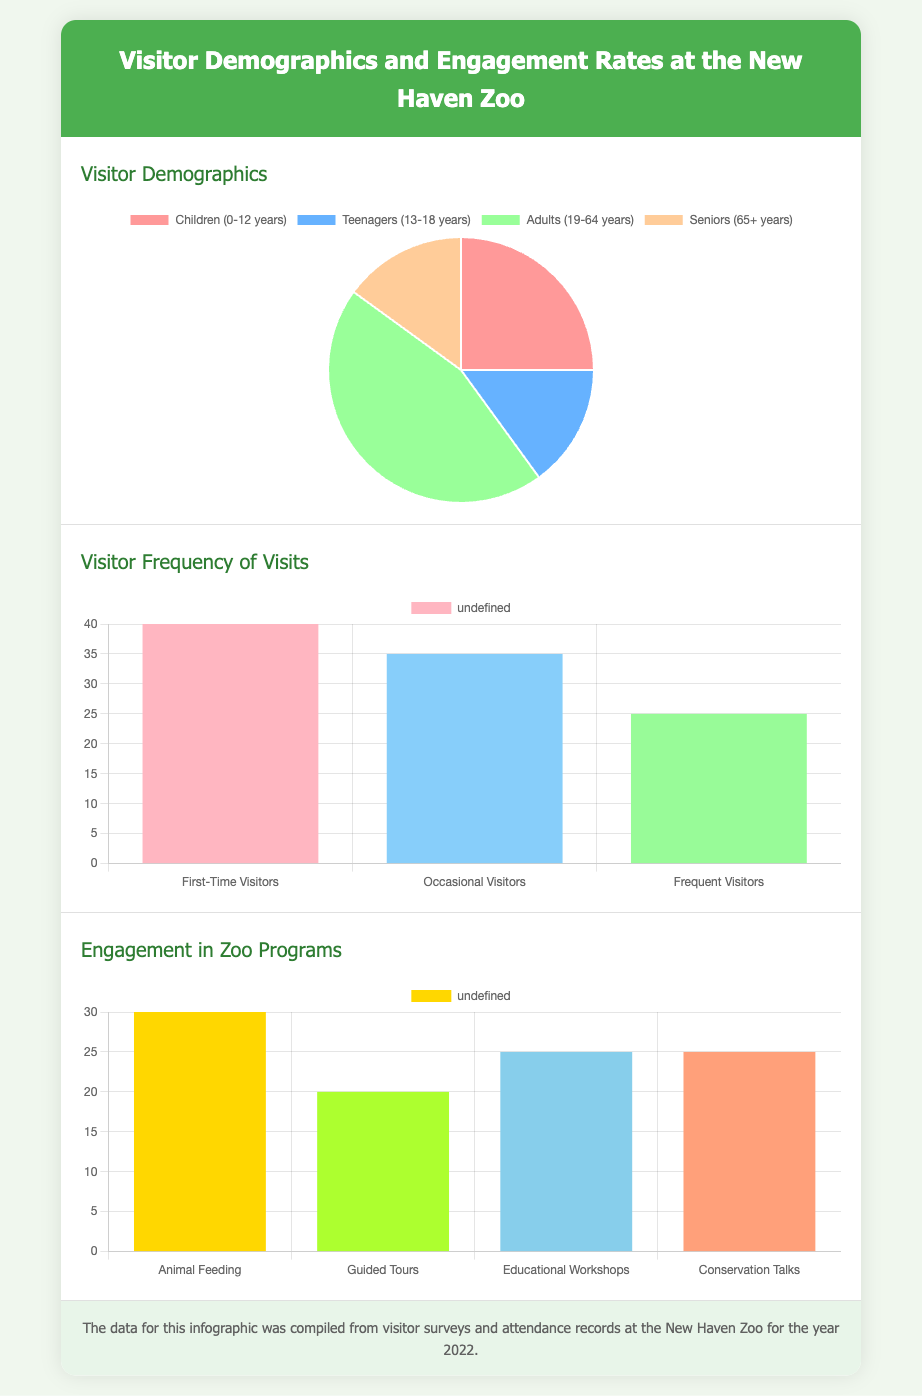What percentage of visitors are adults aged 19-64 years? The demographics chart shows that adults aged 19-64 years represent 45% of the visitors.
Answer: 45% What is the number of first-time visitors? The frequency chart indicates that there are 40 first-time visitors.
Answer: 40 Which engagement program has the highest participation rate? The engagement chart shows that Animal Feeding has the highest participation rate at 30.
Answer: Animal Feeding What is the total percentage of visitors who are seniors (65+ years)? According to the demographics chart, seniors represent 15% of the visitors.
Answer: 15% What is the frequency of occasional visitors? The bar chart indicates there are 35 occasional visitors.
Answer: 35 What is the combined participation rate of guided tours and educational workshops? The engagement chart displays guided tours (20) and educational workshops (25), giving a total of 45.
Answer: 45 What color represents teenagers in the demographics chart? The demographics chart uses the color light blue, corresponding to teenagers.
Answer: Light Blue How many different programs are listed under engagement rates? There are four programs listed: Animal Feeding, Guided Tours, Educational Workshops, and Conservation Talks.
Answer: Four 